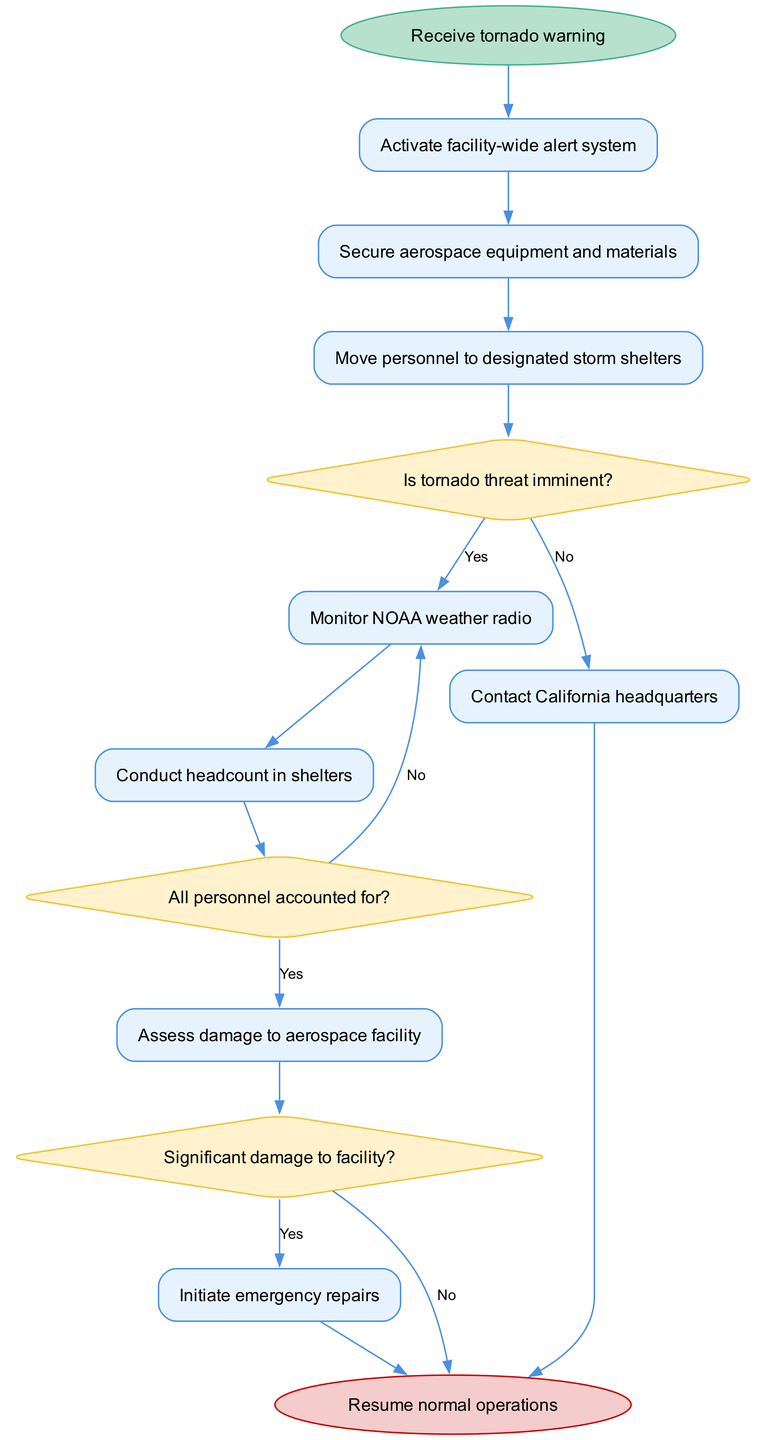What's the first activity after receiving a tornado warning? The diagram shows the flow beginning from the "Receive tornado warning" node, and the first activity connected to this node is "Activate facility-wide alert system."
Answer: Activate facility-wide alert system How many activities are listed in the diagram? There are a total of 8 activities listed in the diagram, as seen in the activities section.
Answer: 8 What decision node follows the personnel moving to storm shelters? After "Move personnel to designated storm shelters," the next decision node is "Is tornado threat imminent?" which is the immediate logical step in the sequence.
Answer: Is tornado threat imminent? In which activity is damage to the aerospace facility assessed? The activity that assesses damage is "Assess damage to aerospace facility," which comes directly after the decision node regarding whether all personnel are accounted for.
Answer: Assess damage to aerospace facility What happens if the tornado threat is not imminent? If the tornado threat is not imminent, as indicated by the "No" edge from the decision node "Is tornado threat imminent?" the next activity is "Contact California headquarters."
Answer: Contact California headquarters How many decisions follow the activity of monitoring the NOAA weather radio? Following the activity of monitoring the NOAA weather radio, there is one decision node, which is "All personnel accounted for?" that follows.
Answer: 1 What is the last activity before resuming normal operations? The last activity before resuming normal operations is "Initiate emergency repairs," which takes place after assessing damage if there is significant damage indicated.
Answer: Initiate emergency repairs After assessing damage, what is the next possible action if there is no significant damage? If there is no significant damage after the assessment, indicated by a "No" from the decision node "Significant damage to facility?", the next action is to resume normal operations.
Answer: Resume normal operations 